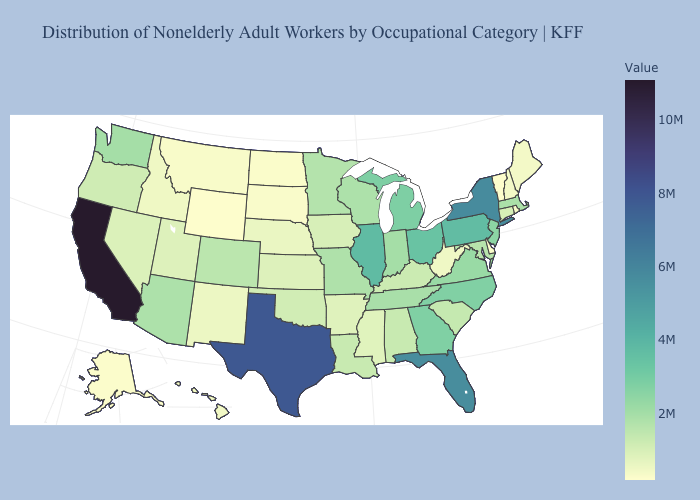Among the states that border Wisconsin , which have the highest value?
Be succinct. Illinois. Which states hav the highest value in the MidWest?
Keep it brief. Illinois. Which states have the highest value in the USA?
Give a very brief answer. California. Does California have the highest value in the West?
Keep it brief. Yes. Among the states that border Wyoming , does South Dakota have the lowest value?
Give a very brief answer. Yes. Among the states that border Missouri , does Nebraska have the lowest value?
Write a very short answer. Yes. 